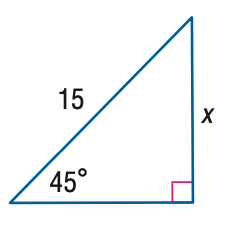Question: Find x.
Choices:
A. \frac { 15 } { 2 }
B. \frac { 15 \sqrt { 2 } } { 2 }
C. \frac { 15 \sqrt { 3 } } { 2 }
D. 15 \sqrt { 2 }
Answer with the letter. Answer: B 